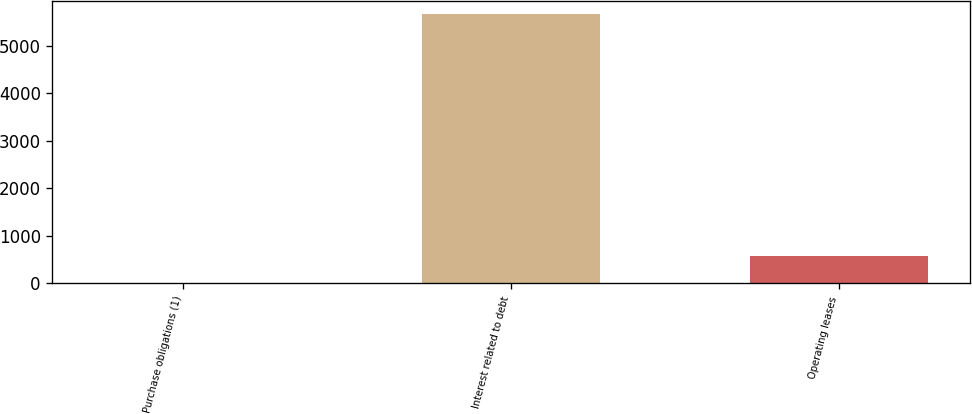Convert chart. <chart><loc_0><loc_0><loc_500><loc_500><bar_chart><fcel>Purchase obligations (1)<fcel>Interest related to debt<fcel>Operating leases<nl><fcel>9<fcel>5659<fcel>574<nl></chart> 